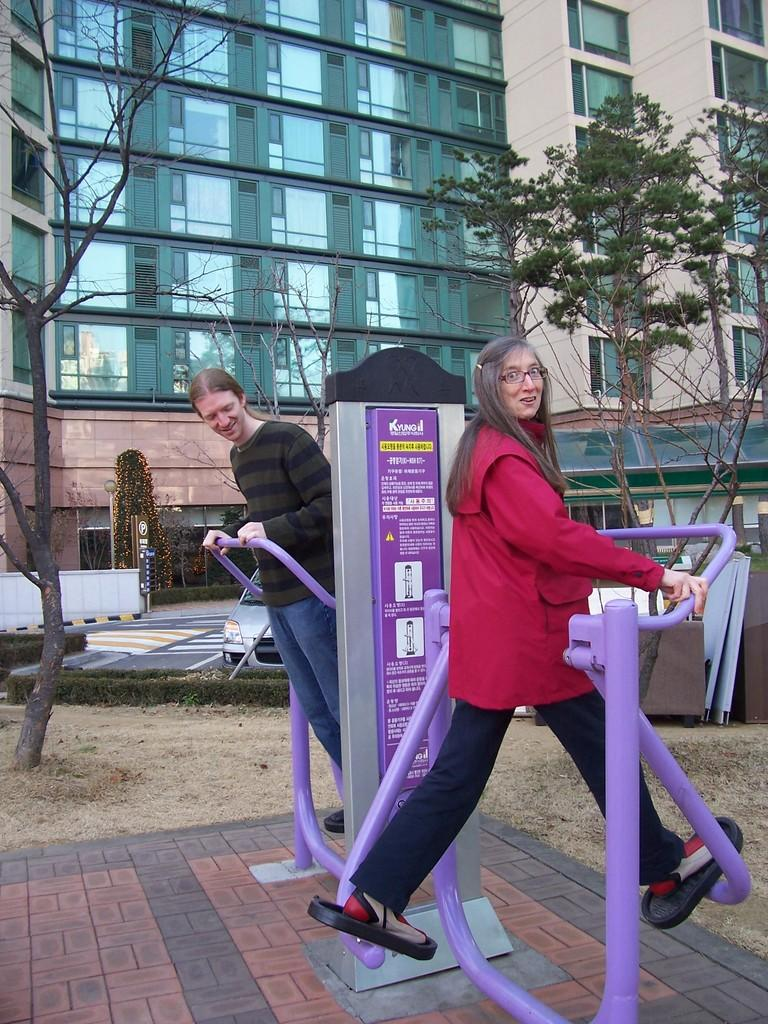How many people are in the image? There are two persons standing in the image. What are the persons doing in the image? The persons are standing on an object. What can be seen in the distance behind the persons? There are buildings and trees in the background of the image. Are there any other objects visible on the ground in the background? Yes, there are other objects on the ground in the background of the image. What type of soap is being used by the persons in the image? There is no soap present in the image; the persons are standing on an object. How many copies of the same object are visible in the image? There is no mention of multiple copies of an object in the image; only one object is mentioned, on which the persons are standing. 